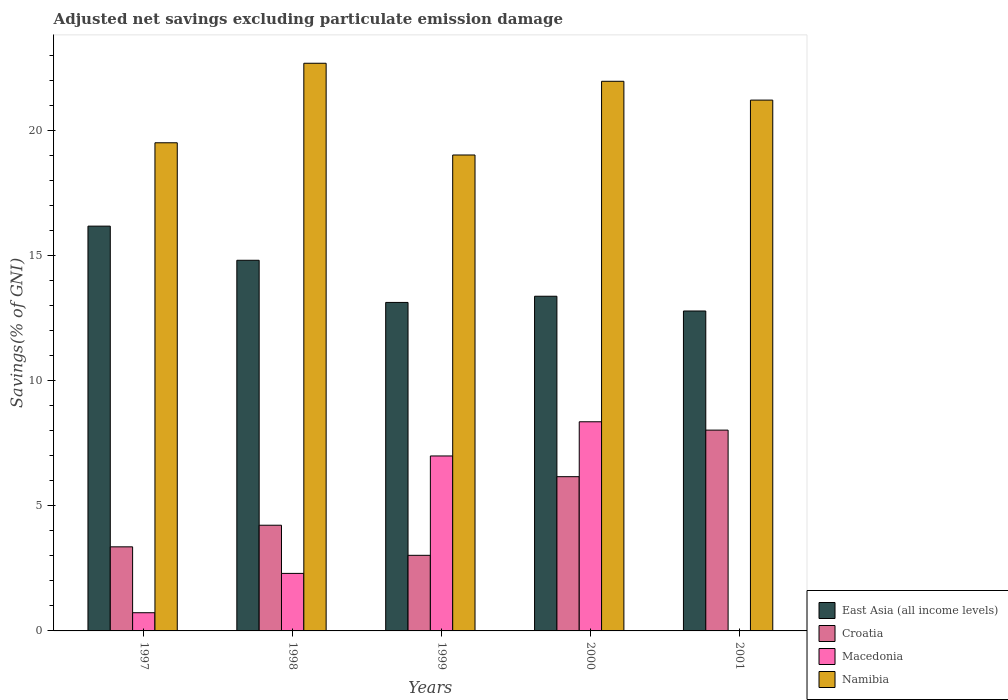How many groups of bars are there?
Provide a succinct answer. 5. Are the number of bars per tick equal to the number of legend labels?
Ensure brevity in your answer.  No. How many bars are there on the 1st tick from the left?
Provide a succinct answer. 4. What is the label of the 4th group of bars from the left?
Provide a short and direct response. 2000. In how many cases, is the number of bars for a given year not equal to the number of legend labels?
Provide a succinct answer. 1. What is the adjusted net savings in Croatia in 1997?
Provide a succinct answer. 3.36. Across all years, what is the maximum adjusted net savings in East Asia (all income levels)?
Make the answer very short. 16.18. Across all years, what is the minimum adjusted net savings in Croatia?
Your answer should be very brief. 3.02. In which year was the adjusted net savings in East Asia (all income levels) maximum?
Offer a terse response. 1997. What is the total adjusted net savings in Macedonia in the graph?
Give a very brief answer. 18.38. What is the difference between the adjusted net savings in Croatia in 1997 and that in 2001?
Give a very brief answer. -4.67. What is the difference between the adjusted net savings in East Asia (all income levels) in 1998 and the adjusted net savings in Croatia in 1999?
Your response must be concise. 11.79. What is the average adjusted net savings in Namibia per year?
Offer a terse response. 20.88. In the year 1998, what is the difference between the adjusted net savings in Namibia and adjusted net savings in Croatia?
Give a very brief answer. 18.47. In how many years, is the adjusted net savings in East Asia (all income levels) greater than 4 %?
Provide a short and direct response. 5. What is the ratio of the adjusted net savings in East Asia (all income levels) in 2000 to that in 2001?
Give a very brief answer. 1.05. Is the adjusted net savings in Croatia in 1998 less than that in 2000?
Provide a succinct answer. Yes. Is the difference between the adjusted net savings in Namibia in 2000 and 2001 greater than the difference between the adjusted net savings in Croatia in 2000 and 2001?
Offer a terse response. Yes. What is the difference between the highest and the second highest adjusted net savings in Croatia?
Your answer should be compact. 1.86. What is the difference between the highest and the lowest adjusted net savings in Croatia?
Your answer should be compact. 5. Is it the case that in every year, the sum of the adjusted net savings in East Asia (all income levels) and adjusted net savings in Croatia is greater than the sum of adjusted net savings in Namibia and adjusted net savings in Macedonia?
Offer a terse response. Yes. How many bars are there?
Your response must be concise. 19. Are all the bars in the graph horizontal?
Your response must be concise. No. What is the difference between two consecutive major ticks on the Y-axis?
Ensure brevity in your answer.  5. Does the graph contain grids?
Ensure brevity in your answer.  No. Where does the legend appear in the graph?
Keep it short and to the point. Bottom right. What is the title of the graph?
Keep it short and to the point. Adjusted net savings excluding particulate emission damage. Does "Sint Maarten (Dutch part)" appear as one of the legend labels in the graph?
Offer a terse response. No. What is the label or title of the Y-axis?
Provide a succinct answer. Savings(% of GNI). What is the Savings(% of GNI) of East Asia (all income levels) in 1997?
Your answer should be compact. 16.18. What is the Savings(% of GNI) of Croatia in 1997?
Keep it short and to the point. 3.36. What is the Savings(% of GNI) in Macedonia in 1997?
Ensure brevity in your answer.  0.73. What is the Savings(% of GNI) of Namibia in 1997?
Keep it short and to the point. 19.51. What is the Savings(% of GNI) in East Asia (all income levels) in 1998?
Provide a short and direct response. 14.81. What is the Savings(% of GNI) in Croatia in 1998?
Your response must be concise. 4.22. What is the Savings(% of GNI) of Macedonia in 1998?
Give a very brief answer. 2.3. What is the Savings(% of GNI) of Namibia in 1998?
Give a very brief answer. 22.69. What is the Savings(% of GNI) of East Asia (all income levels) in 1999?
Your response must be concise. 13.13. What is the Savings(% of GNI) in Croatia in 1999?
Offer a terse response. 3.02. What is the Savings(% of GNI) in Macedonia in 1999?
Provide a short and direct response. 6.99. What is the Savings(% of GNI) of Namibia in 1999?
Make the answer very short. 19.02. What is the Savings(% of GNI) of East Asia (all income levels) in 2000?
Give a very brief answer. 13.38. What is the Savings(% of GNI) in Croatia in 2000?
Your answer should be very brief. 6.16. What is the Savings(% of GNI) in Macedonia in 2000?
Give a very brief answer. 8.36. What is the Savings(% of GNI) in Namibia in 2000?
Provide a succinct answer. 21.97. What is the Savings(% of GNI) of East Asia (all income levels) in 2001?
Your response must be concise. 12.79. What is the Savings(% of GNI) of Croatia in 2001?
Ensure brevity in your answer.  8.03. What is the Savings(% of GNI) in Namibia in 2001?
Keep it short and to the point. 21.22. Across all years, what is the maximum Savings(% of GNI) in East Asia (all income levels)?
Give a very brief answer. 16.18. Across all years, what is the maximum Savings(% of GNI) of Croatia?
Your answer should be very brief. 8.03. Across all years, what is the maximum Savings(% of GNI) of Macedonia?
Your answer should be very brief. 8.36. Across all years, what is the maximum Savings(% of GNI) in Namibia?
Offer a terse response. 22.69. Across all years, what is the minimum Savings(% of GNI) of East Asia (all income levels)?
Your answer should be compact. 12.79. Across all years, what is the minimum Savings(% of GNI) in Croatia?
Offer a terse response. 3.02. Across all years, what is the minimum Savings(% of GNI) of Namibia?
Your answer should be compact. 19.02. What is the total Savings(% of GNI) in East Asia (all income levels) in the graph?
Your response must be concise. 70.29. What is the total Savings(% of GNI) in Croatia in the graph?
Keep it short and to the point. 24.8. What is the total Savings(% of GNI) of Macedonia in the graph?
Provide a short and direct response. 18.38. What is the total Savings(% of GNI) of Namibia in the graph?
Give a very brief answer. 104.41. What is the difference between the Savings(% of GNI) in East Asia (all income levels) in 1997 and that in 1998?
Provide a short and direct response. 1.36. What is the difference between the Savings(% of GNI) in Croatia in 1997 and that in 1998?
Keep it short and to the point. -0.86. What is the difference between the Savings(% of GNI) of Macedonia in 1997 and that in 1998?
Make the answer very short. -1.57. What is the difference between the Savings(% of GNI) in Namibia in 1997 and that in 1998?
Ensure brevity in your answer.  -3.18. What is the difference between the Savings(% of GNI) of East Asia (all income levels) in 1997 and that in 1999?
Your response must be concise. 3.05. What is the difference between the Savings(% of GNI) in Croatia in 1997 and that in 1999?
Offer a very short reply. 0.34. What is the difference between the Savings(% of GNI) in Macedonia in 1997 and that in 1999?
Provide a short and direct response. -6.27. What is the difference between the Savings(% of GNI) of Namibia in 1997 and that in 1999?
Give a very brief answer. 0.49. What is the difference between the Savings(% of GNI) of East Asia (all income levels) in 1997 and that in 2000?
Your answer should be compact. 2.8. What is the difference between the Savings(% of GNI) of Croatia in 1997 and that in 2000?
Keep it short and to the point. -2.8. What is the difference between the Savings(% of GNI) in Macedonia in 1997 and that in 2000?
Your answer should be very brief. -7.63. What is the difference between the Savings(% of GNI) in Namibia in 1997 and that in 2000?
Provide a succinct answer. -2.46. What is the difference between the Savings(% of GNI) of East Asia (all income levels) in 1997 and that in 2001?
Provide a short and direct response. 3.39. What is the difference between the Savings(% of GNI) of Croatia in 1997 and that in 2001?
Give a very brief answer. -4.67. What is the difference between the Savings(% of GNI) of Namibia in 1997 and that in 2001?
Make the answer very short. -1.71. What is the difference between the Savings(% of GNI) in East Asia (all income levels) in 1998 and that in 1999?
Your answer should be very brief. 1.69. What is the difference between the Savings(% of GNI) in Croatia in 1998 and that in 1999?
Provide a succinct answer. 1.2. What is the difference between the Savings(% of GNI) in Macedonia in 1998 and that in 1999?
Provide a short and direct response. -4.69. What is the difference between the Savings(% of GNI) in Namibia in 1998 and that in 1999?
Offer a very short reply. 3.67. What is the difference between the Savings(% of GNI) in East Asia (all income levels) in 1998 and that in 2000?
Offer a terse response. 1.44. What is the difference between the Savings(% of GNI) of Croatia in 1998 and that in 2000?
Offer a terse response. -1.94. What is the difference between the Savings(% of GNI) of Macedonia in 1998 and that in 2000?
Give a very brief answer. -6.06. What is the difference between the Savings(% of GNI) of Namibia in 1998 and that in 2000?
Keep it short and to the point. 0.72. What is the difference between the Savings(% of GNI) of East Asia (all income levels) in 1998 and that in 2001?
Keep it short and to the point. 2.03. What is the difference between the Savings(% of GNI) of Croatia in 1998 and that in 2001?
Give a very brief answer. -3.8. What is the difference between the Savings(% of GNI) in Namibia in 1998 and that in 2001?
Provide a succinct answer. 1.47. What is the difference between the Savings(% of GNI) of East Asia (all income levels) in 1999 and that in 2000?
Your answer should be compact. -0.25. What is the difference between the Savings(% of GNI) in Croatia in 1999 and that in 2000?
Ensure brevity in your answer.  -3.14. What is the difference between the Savings(% of GNI) of Macedonia in 1999 and that in 2000?
Ensure brevity in your answer.  -1.37. What is the difference between the Savings(% of GNI) in Namibia in 1999 and that in 2000?
Make the answer very short. -2.95. What is the difference between the Savings(% of GNI) in East Asia (all income levels) in 1999 and that in 2001?
Ensure brevity in your answer.  0.34. What is the difference between the Savings(% of GNI) of Croatia in 1999 and that in 2001?
Keep it short and to the point. -5. What is the difference between the Savings(% of GNI) of Namibia in 1999 and that in 2001?
Keep it short and to the point. -2.19. What is the difference between the Savings(% of GNI) in East Asia (all income levels) in 2000 and that in 2001?
Your answer should be compact. 0.59. What is the difference between the Savings(% of GNI) in Croatia in 2000 and that in 2001?
Make the answer very short. -1.86. What is the difference between the Savings(% of GNI) in Namibia in 2000 and that in 2001?
Provide a succinct answer. 0.75. What is the difference between the Savings(% of GNI) in East Asia (all income levels) in 1997 and the Savings(% of GNI) in Croatia in 1998?
Keep it short and to the point. 11.96. What is the difference between the Savings(% of GNI) in East Asia (all income levels) in 1997 and the Savings(% of GNI) in Macedonia in 1998?
Offer a very short reply. 13.88. What is the difference between the Savings(% of GNI) of East Asia (all income levels) in 1997 and the Savings(% of GNI) of Namibia in 1998?
Your response must be concise. -6.51. What is the difference between the Savings(% of GNI) in Croatia in 1997 and the Savings(% of GNI) in Macedonia in 1998?
Offer a terse response. 1.06. What is the difference between the Savings(% of GNI) of Croatia in 1997 and the Savings(% of GNI) of Namibia in 1998?
Make the answer very short. -19.33. What is the difference between the Savings(% of GNI) of Macedonia in 1997 and the Savings(% of GNI) of Namibia in 1998?
Your response must be concise. -21.96. What is the difference between the Savings(% of GNI) in East Asia (all income levels) in 1997 and the Savings(% of GNI) in Croatia in 1999?
Your response must be concise. 13.16. What is the difference between the Savings(% of GNI) in East Asia (all income levels) in 1997 and the Savings(% of GNI) in Macedonia in 1999?
Your response must be concise. 9.19. What is the difference between the Savings(% of GNI) in East Asia (all income levels) in 1997 and the Savings(% of GNI) in Namibia in 1999?
Provide a succinct answer. -2.84. What is the difference between the Savings(% of GNI) in Croatia in 1997 and the Savings(% of GNI) in Macedonia in 1999?
Provide a short and direct response. -3.63. What is the difference between the Savings(% of GNI) in Croatia in 1997 and the Savings(% of GNI) in Namibia in 1999?
Your answer should be very brief. -15.66. What is the difference between the Savings(% of GNI) of Macedonia in 1997 and the Savings(% of GNI) of Namibia in 1999?
Ensure brevity in your answer.  -18.3. What is the difference between the Savings(% of GNI) of East Asia (all income levels) in 1997 and the Savings(% of GNI) of Croatia in 2000?
Your answer should be compact. 10.01. What is the difference between the Savings(% of GNI) of East Asia (all income levels) in 1997 and the Savings(% of GNI) of Macedonia in 2000?
Your response must be concise. 7.82. What is the difference between the Savings(% of GNI) of East Asia (all income levels) in 1997 and the Savings(% of GNI) of Namibia in 2000?
Provide a short and direct response. -5.79. What is the difference between the Savings(% of GNI) of Croatia in 1997 and the Savings(% of GNI) of Macedonia in 2000?
Make the answer very short. -5. What is the difference between the Savings(% of GNI) of Croatia in 1997 and the Savings(% of GNI) of Namibia in 2000?
Offer a terse response. -18.61. What is the difference between the Savings(% of GNI) of Macedonia in 1997 and the Savings(% of GNI) of Namibia in 2000?
Your answer should be compact. -21.24. What is the difference between the Savings(% of GNI) in East Asia (all income levels) in 1997 and the Savings(% of GNI) in Croatia in 2001?
Offer a terse response. 8.15. What is the difference between the Savings(% of GNI) of East Asia (all income levels) in 1997 and the Savings(% of GNI) of Namibia in 2001?
Provide a succinct answer. -5.04. What is the difference between the Savings(% of GNI) of Croatia in 1997 and the Savings(% of GNI) of Namibia in 2001?
Offer a very short reply. -17.86. What is the difference between the Savings(% of GNI) in Macedonia in 1997 and the Savings(% of GNI) in Namibia in 2001?
Ensure brevity in your answer.  -20.49. What is the difference between the Savings(% of GNI) of East Asia (all income levels) in 1998 and the Savings(% of GNI) of Croatia in 1999?
Your response must be concise. 11.79. What is the difference between the Savings(% of GNI) in East Asia (all income levels) in 1998 and the Savings(% of GNI) in Macedonia in 1999?
Offer a very short reply. 7.82. What is the difference between the Savings(% of GNI) in East Asia (all income levels) in 1998 and the Savings(% of GNI) in Namibia in 1999?
Provide a short and direct response. -4.21. What is the difference between the Savings(% of GNI) in Croatia in 1998 and the Savings(% of GNI) in Macedonia in 1999?
Your response must be concise. -2.77. What is the difference between the Savings(% of GNI) in Croatia in 1998 and the Savings(% of GNI) in Namibia in 1999?
Your response must be concise. -14.8. What is the difference between the Savings(% of GNI) of Macedonia in 1998 and the Savings(% of GNI) of Namibia in 1999?
Give a very brief answer. -16.72. What is the difference between the Savings(% of GNI) of East Asia (all income levels) in 1998 and the Savings(% of GNI) of Croatia in 2000?
Ensure brevity in your answer.  8.65. What is the difference between the Savings(% of GNI) in East Asia (all income levels) in 1998 and the Savings(% of GNI) in Macedonia in 2000?
Offer a very short reply. 6.46. What is the difference between the Savings(% of GNI) in East Asia (all income levels) in 1998 and the Savings(% of GNI) in Namibia in 2000?
Ensure brevity in your answer.  -7.15. What is the difference between the Savings(% of GNI) in Croatia in 1998 and the Savings(% of GNI) in Macedonia in 2000?
Offer a very short reply. -4.14. What is the difference between the Savings(% of GNI) in Croatia in 1998 and the Savings(% of GNI) in Namibia in 2000?
Give a very brief answer. -17.74. What is the difference between the Savings(% of GNI) of Macedonia in 1998 and the Savings(% of GNI) of Namibia in 2000?
Ensure brevity in your answer.  -19.67. What is the difference between the Savings(% of GNI) in East Asia (all income levels) in 1998 and the Savings(% of GNI) in Croatia in 2001?
Offer a terse response. 6.79. What is the difference between the Savings(% of GNI) in East Asia (all income levels) in 1998 and the Savings(% of GNI) in Namibia in 2001?
Your answer should be compact. -6.4. What is the difference between the Savings(% of GNI) of Croatia in 1998 and the Savings(% of GNI) of Namibia in 2001?
Ensure brevity in your answer.  -16.99. What is the difference between the Savings(% of GNI) of Macedonia in 1998 and the Savings(% of GNI) of Namibia in 2001?
Keep it short and to the point. -18.92. What is the difference between the Savings(% of GNI) in East Asia (all income levels) in 1999 and the Savings(% of GNI) in Croatia in 2000?
Your response must be concise. 6.96. What is the difference between the Savings(% of GNI) of East Asia (all income levels) in 1999 and the Savings(% of GNI) of Macedonia in 2000?
Provide a short and direct response. 4.77. What is the difference between the Savings(% of GNI) of East Asia (all income levels) in 1999 and the Savings(% of GNI) of Namibia in 2000?
Provide a short and direct response. -8.84. What is the difference between the Savings(% of GNI) in Croatia in 1999 and the Savings(% of GNI) in Macedonia in 2000?
Your answer should be very brief. -5.34. What is the difference between the Savings(% of GNI) in Croatia in 1999 and the Savings(% of GNI) in Namibia in 2000?
Ensure brevity in your answer.  -18.95. What is the difference between the Savings(% of GNI) of Macedonia in 1999 and the Savings(% of GNI) of Namibia in 2000?
Your answer should be compact. -14.98. What is the difference between the Savings(% of GNI) of East Asia (all income levels) in 1999 and the Savings(% of GNI) of Croatia in 2001?
Ensure brevity in your answer.  5.1. What is the difference between the Savings(% of GNI) of East Asia (all income levels) in 1999 and the Savings(% of GNI) of Namibia in 2001?
Provide a short and direct response. -8.09. What is the difference between the Savings(% of GNI) of Croatia in 1999 and the Savings(% of GNI) of Namibia in 2001?
Your response must be concise. -18.2. What is the difference between the Savings(% of GNI) of Macedonia in 1999 and the Savings(% of GNI) of Namibia in 2001?
Offer a terse response. -14.22. What is the difference between the Savings(% of GNI) in East Asia (all income levels) in 2000 and the Savings(% of GNI) in Croatia in 2001?
Give a very brief answer. 5.35. What is the difference between the Savings(% of GNI) in East Asia (all income levels) in 2000 and the Savings(% of GNI) in Namibia in 2001?
Offer a very short reply. -7.84. What is the difference between the Savings(% of GNI) of Croatia in 2000 and the Savings(% of GNI) of Namibia in 2001?
Offer a terse response. -15.05. What is the difference between the Savings(% of GNI) of Macedonia in 2000 and the Savings(% of GNI) of Namibia in 2001?
Your answer should be compact. -12.86. What is the average Savings(% of GNI) in East Asia (all income levels) per year?
Keep it short and to the point. 14.06. What is the average Savings(% of GNI) of Croatia per year?
Make the answer very short. 4.96. What is the average Savings(% of GNI) of Macedonia per year?
Provide a succinct answer. 3.68. What is the average Savings(% of GNI) of Namibia per year?
Provide a succinct answer. 20.88. In the year 1997, what is the difference between the Savings(% of GNI) in East Asia (all income levels) and Savings(% of GNI) in Croatia?
Your response must be concise. 12.82. In the year 1997, what is the difference between the Savings(% of GNI) in East Asia (all income levels) and Savings(% of GNI) in Macedonia?
Your answer should be compact. 15.45. In the year 1997, what is the difference between the Savings(% of GNI) of East Asia (all income levels) and Savings(% of GNI) of Namibia?
Make the answer very short. -3.33. In the year 1997, what is the difference between the Savings(% of GNI) in Croatia and Savings(% of GNI) in Macedonia?
Your answer should be compact. 2.63. In the year 1997, what is the difference between the Savings(% of GNI) of Croatia and Savings(% of GNI) of Namibia?
Provide a succinct answer. -16.15. In the year 1997, what is the difference between the Savings(% of GNI) of Macedonia and Savings(% of GNI) of Namibia?
Your answer should be very brief. -18.78. In the year 1998, what is the difference between the Savings(% of GNI) in East Asia (all income levels) and Savings(% of GNI) in Croatia?
Give a very brief answer. 10.59. In the year 1998, what is the difference between the Savings(% of GNI) of East Asia (all income levels) and Savings(% of GNI) of Macedonia?
Provide a short and direct response. 12.52. In the year 1998, what is the difference between the Savings(% of GNI) in East Asia (all income levels) and Savings(% of GNI) in Namibia?
Keep it short and to the point. -7.87. In the year 1998, what is the difference between the Savings(% of GNI) in Croatia and Savings(% of GNI) in Macedonia?
Your answer should be very brief. 1.93. In the year 1998, what is the difference between the Savings(% of GNI) of Croatia and Savings(% of GNI) of Namibia?
Your answer should be compact. -18.47. In the year 1998, what is the difference between the Savings(% of GNI) in Macedonia and Savings(% of GNI) in Namibia?
Your response must be concise. -20.39. In the year 1999, what is the difference between the Savings(% of GNI) of East Asia (all income levels) and Savings(% of GNI) of Croatia?
Your answer should be compact. 10.11. In the year 1999, what is the difference between the Savings(% of GNI) of East Asia (all income levels) and Savings(% of GNI) of Macedonia?
Your answer should be compact. 6.14. In the year 1999, what is the difference between the Savings(% of GNI) in East Asia (all income levels) and Savings(% of GNI) in Namibia?
Your response must be concise. -5.89. In the year 1999, what is the difference between the Savings(% of GNI) of Croatia and Savings(% of GNI) of Macedonia?
Ensure brevity in your answer.  -3.97. In the year 1999, what is the difference between the Savings(% of GNI) of Croatia and Savings(% of GNI) of Namibia?
Keep it short and to the point. -16. In the year 1999, what is the difference between the Savings(% of GNI) of Macedonia and Savings(% of GNI) of Namibia?
Your response must be concise. -12.03. In the year 2000, what is the difference between the Savings(% of GNI) in East Asia (all income levels) and Savings(% of GNI) in Croatia?
Your answer should be compact. 7.21. In the year 2000, what is the difference between the Savings(% of GNI) in East Asia (all income levels) and Savings(% of GNI) in Macedonia?
Give a very brief answer. 5.02. In the year 2000, what is the difference between the Savings(% of GNI) of East Asia (all income levels) and Savings(% of GNI) of Namibia?
Give a very brief answer. -8.59. In the year 2000, what is the difference between the Savings(% of GNI) of Croatia and Savings(% of GNI) of Macedonia?
Provide a short and direct response. -2.19. In the year 2000, what is the difference between the Savings(% of GNI) of Croatia and Savings(% of GNI) of Namibia?
Your response must be concise. -15.8. In the year 2000, what is the difference between the Savings(% of GNI) in Macedonia and Savings(% of GNI) in Namibia?
Offer a terse response. -13.61. In the year 2001, what is the difference between the Savings(% of GNI) in East Asia (all income levels) and Savings(% of GNI) in Croatia?
Give a very brief answer. 4.76. In the year 2001, what is the difference between the Savings(% of GNI) of East Asia (all income levels) and Savings(% of GNI) of Namibia?
Offer a very short reply. -8.43. In the year 2001, what is the difference between the Savings(% of GNI) of Croatia and Savings(% of GNI) of Namibia?
Your response must be concise. -13.19. What is the ratio of the Savings(% of GNI) in East Asia (all income levels) in 1997 to that in 1998?
Your response must be concise. 1.09. What is the ratio of the Savings(% of GNI) of Croatia in 1997 to that in 1998?
Ensure brevity in your answer.  0.8. What is the ratio of the Savings(% of GNI) in Macedonia in 1997 to that in 1998?
Offer a terse response. 0.32. What is the ratio of the Savings(% of GNI) in Namibia in 1997 to that in 1998?
Make the answer very short. 0.86. What is the ratio of the Savings(% of GNI) in East Asia (all income levels) in 1997 to that in 1999?
Provide a short and direct response. 1.23. What is the ratio of the Savings(% of GNI) of Croatia in 1997 to that in 1999?
Give a very brief answer. 1.11. What is the ratio of the Savings(% of GNI) in Macedonia in 1997 to that in 1999?
Provide a short and direct response. 0.1. What is the ratio of the Savings(% of GNI) in Namibia in 1997 to that in 1999?
Keep it short and to the point. 1.03. What is the ratio of the Savings(% of GNI) in East Asia (all income levels) in 1997 to that in 2000?
Offer a very short reply. 1.21. What is the ratio of the Savings(% of GNI) in Croatia in 1997 to that in 2000?
Give a very brief answer. 0.55. What is the ratio of the Savings(% of GNI) in Macedonia in 1997 to that in 2000?
Offer a terse response. 0.09. What is the ratio of the Savings(% of GNI) of Namibia in 1997 to that in 2000?
Provide a succinct answer. 0.89. What is the ratio of the Savings(% of GNI) in East Asia (all income levels) in 1997 to that in 2001?
Give a very brief answer. 1.27. What is the ratio of the Savings(% of GNI) of Croatia in 1997 to that in 2001?
Your answer should be very brief. 0.42. What is the ratio of the Savings(% of GNI) in Namibia in 1997 to that in 2001?
Your answer should be very brief. 0.92. What is the ratio of the Savings(% of GNI) of East Asia (all income levels) in 1998 to that in 1999?
Make the answer very short. 1.13. What is the ratio of the Savings(% of GNI) of Croatia in 1998 to that in 1999?
Ensure brevity in your answer.  1.4. What is the ratio of the Savings(% of GNI) in Macedonia in 1998 to that in 1999?
Your answer should be very brief. 0.33. What is the ratio of the Savings(% of GNI) in Namibia in 1998 to that in 1999?
Your answer should be very brief. 1.19. What is the ratio of the Savings(% of GNI) of East Asia (all income levels) in 1998 to that in 2000?
Ensure brevity in your answer.  1.11. What is the ratio of the Savings(% of GNI) of Croatia in 1998 to that in 2000?
Offer a terse response. 0.69. What is the ratio of the Savings(% of GNI) in Macedonia in 1998 to that in 2000?
Offer a terse response. 0.28. What is the ratio of the Savings(% of GNI) in Namibia in 1998 to that in 2000?
Make the answer very short. 1.03. What is the ratio of the Savings(% of GNI) in East Asia (all income levels) in 1998 to that in 2001?
Your answer should be very brief. 1.16. What is the ratio of the Savings(% of GNI) in Croatia in 1998 to that in 2001?
Give a very brief answer. 0.53. What is the ratio of the Savings(% of GNI) in Namibia in 1998 to that in 2001?
Provide a succinct answer. 1.07. What is the ratio of the Savings(% of GNI) in East Asia (all income levels) in 1999 to that in 2000?
Provide a succinct answer. 0.98. What is the ratio of the Savings(% of GNI) in Croatia in 1999 to that in 2000?
Offer a very short reply. 0.49. What is the ratio of the Savings(% of GNI) in Macedonia in 1999 to that in 2000?
Make the answer very short. 0.84. What is the ratio of the Savings(% of GNI) of Namibia in 1999 to that in 2000?
Your answer should be very brief. 0.87. What is the ratio of the Savings(% of GNI) of East Asia (all income levels) in 1999 to that in 2001?
Offer a terse response. 1.03. What is the ratio of the Savings(% of GNI) in Croatia in 1999 to that in 2001?
Your answer should be very brief. 0.38. What is the ratio of the Savings(% of GNI) of Namibia in 1999 to that in 2001?
Make the answer very short. 0.9. What is the ratio of the Savings(% of GNI) of East Asia (all income levels) in 2000 to that in 2001?
Your response must be concise. 1.05. What is the ratio of the Savings(% of GNI) in Croatia in 2000 to that in 2001?
Your answer should be compact. 0.77. What is the ratio of the Savings(% of GNI) in Namibia in 2000 to that in 2001?
Offer a terse response. 1.04. What is the difference between the highest and the second highest Savings(% of GNI) in East Asia (all income levels)?
Make the answer very short. 1.36. What is the difference between the highest and the second highest Savings(% of GNI) in Croatia?
Provide a succinct answer. 1.86. What is the difference between the highest and the second highest Savings(% of GNI) in Macedonia?
Your answer should be very brief. 1.37. What is the difference between the highest and the second highest Savings(% of GNI) of Namibia?
Your response must be concise. 0.72. What is the difference between the highest and the lowest Savings(% of GNI) in East Asia (all income levels)?
Keep it short and to the point. 3.39. What is the difference between the highest and the lowest Savings(% of GNI) in Croatia?
Provide a succinct answer. 5. What is the difference between the highest and the lowest Savings(% of GNI) of Macedonia?
Provide a short and direct response. 8.36. What is the difference between the highest and the lowest Savings(% of GNI) in Namibia?
Ensure brevity in your answer.  3.67. 